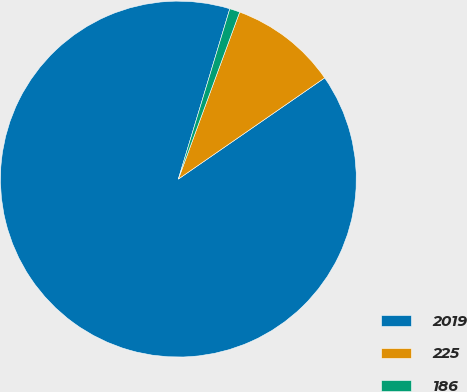Convert chart. <chart><loc_0><loc_0><loc_500><loc_500><pie_chart><fcel>2019<fcel>225<fcel>186<nl><fcel>89.3%<fcel>9.77%<fcel>0.93%<nl></chart> 